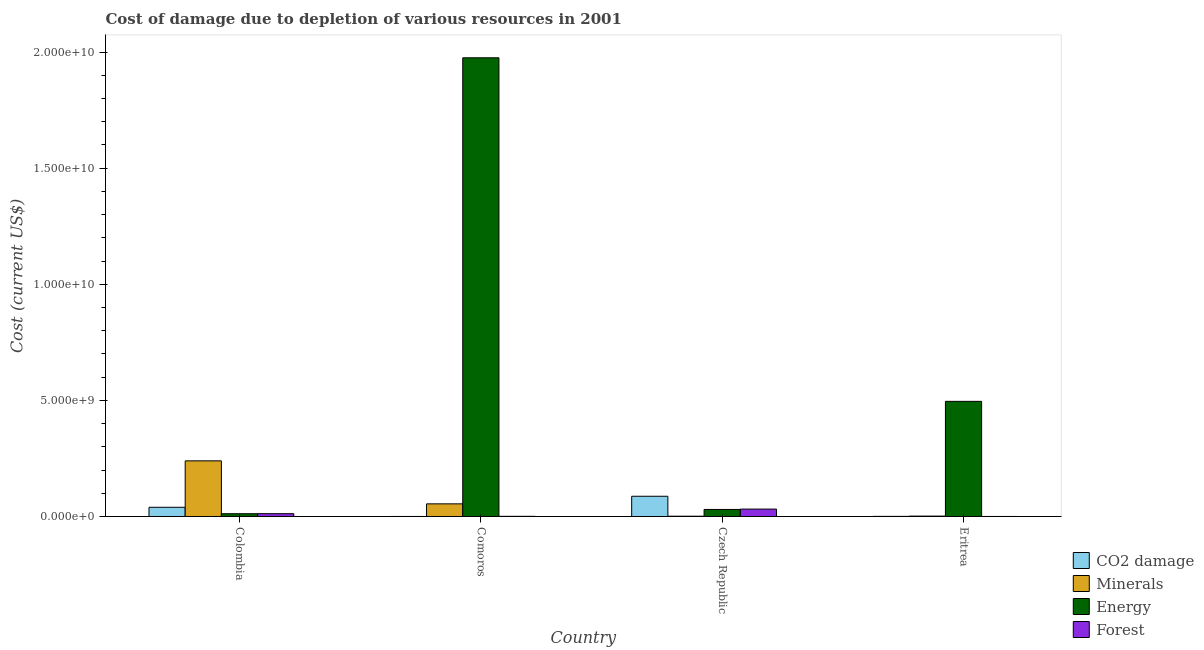How many different coloured bars are there?
Give a very brief answer. 4. How many groups of bars are there?
Provide a short and direct response. 4. What is the label of the 4th group of bars from the left?
Make the answer very short. Eritrea. What is the cost of damage due to depletion of coal in Colombia?
Ensure brevity in your answer.  3.97e+08. Across all countries, what is the maximum cost of damage due to depletion of forests?
Provide a succinct answer. 3.19e+08. Across all countries, what is the minimum cost of damage due to depletion of energy?
Provide a succinct answer. 1.19e+08. In which country was the cost of damage due to depletion of minerals maximum?
Make the answer very short. Colombia. In which country was the cost of damage due to depletion of coal minimum?
Ensure brevity in your answer.  Comoros. What is the total cost of damage due to depletion of minerals in the graph?
Provide a short and direct response. 2.97e+09. What is the difference between the cost of damage due to depletion of coal in Colombia and that in Czech Republic?
Your answer should be compact. -4.74e+08. What is the difference between the cost of damage due to depletion of minerals in Comoros and the cost of damage due to depletion of energy in Czech Republic?
Offer a very short reply. 2.41e+08. What is the average cost of damage due to depletion of minerals per country?
Provide a succinct answer. 7.42e+08. What is the difference between the cost of damage due to depletion of forests and cost of damage due to depletion of energy in Colombia?
Ensure brevity in your answer.  1.68e+06. In how many countries, is the cost of damage due to depletion of minerals greater than 10000000000 US$?
Ensure brevity in your answer.  0. What is the ratio of the cost of damage due to depletion of forests in Comoros to that in Eritrea?
Provide a short and direct response. 157.57. What is the difference between the highest and the second highest cost of damage due to depletion of forests?
Your answer should be very brief. 1.98e+08. What is the difference between the highest and the lowest cost of damage due to depletion of forests?
Offer a terse response. 3.19e+08. In how many countries, is the cost of damage due to depletion of forests greater than the average cost of damage due to depletion of forests taken over all countries?
Offer a terse response. 2. Is it the case that in every country, the sum of the cost of damage due to depletion of forests and cost of damage due to depletion of energy is greater than the sum of cost of damage due to depletion of minerals and cost of damage due to depletion of coal?
Provide a succinct answer. No. What does the 4th bar from the left in Czech Republic represents?
Offer a very short reply. Forest. What does the 1st bar from the right in Comoros represents?
Your answer should be compact. Forest. How many bars are there?
Your answer should be very brief. 16. Are all the bars in the graph horizontal?
Your response must be concise. No. How are the legend labels stacked?
Offer a terse response. Vertical. What is the title of the graph?
Offer a very short reply. Cost of damage due to depletion of various resources in 2001 . What is the label or title of the Y-axis?
Give a very brief answer. Cost (current US$). What is the Cost (current US$) in CO2 damage in Colombia?
Keep it short and to the point. 3.97e+08. What is the Cost (current US$) in Minerals in Colombia?
Give a very brief answer. 2.40e+09. What is the Cost (current US$) in Energy in Colombia?
Offer a terse response. 1.19e+08. What is the Cost (current US$) in Forest in Colombia?
Provide a short and direct response. 1.21e+08. What is the Cost (current US$) in CO2 damage in Comoros?
Your answer should be very brief. 6.20e+05. What is the Cost (current US$) in Minerals in Comoros?
Make the answer very short. 5.44e+08. What is the Cost (current US$) of Energy in Comoros?
Your answer should be very brief. 1.98e+1. What is the Cost (current US$) of Forest in Comoros?
Ensure brevity in your answer.  7.16e+06. What is the Cost (current US$) in CO2 damage in Czech Republic?
Ensure brevity in your answer.  8.71e+08. What is the Cost (current US$) in Minerals in Czech Republic?
Offer a very short reply. 1.20e+07. What is the Cost (current US$) in Energy in Czech Republic?
Give a very brief answer. 3.03e+08. What is the Cost (current US$) in Forest in Czech Republic?
Offer a very short reply. 3.19e+08. What is the Cost (current US$) of CO2 damage in Eritrea?
Make the answer very short. 4.45e+06. What is the Cost (current US$) of Minerals in Eritrea?
Your answer should be very brief. 1.64e+07. What is the Cost (current US$) of Energy in Eritrea?
Your answer should be very brief. 4.96e+09. What is the Cost (current US$) in Forest in Eritrea?
Offer a very short reply. 4.54e+04. Across all countries, what is the maximum Cost (current US$) of CO2 damage?
Keep it short and to the point. 8.71e+08. Across all countries, what is the maximum Cost (current US$) in Minerals?
Keep it short and to the point. 2.40e+09. Across all countries, what is the maximum Cost (current US$) in Energy?
Make the answer very short. 1.98e+1. Across all countries, what is the maximum Cost (current US$) of Forest?
Give a very brief answer. 3.19e+08. Across all countries, what is the minimum Cost (current US$) of CO2 damage?
Your answer should be very brief. 6.20e+05. Across all countries, what is the minimum Cost (current US$) in Minerals?
Keep it short and to the point. 1.20e+07. Across all countries, what is the minimum Cost (current US$) in Energy?
Your answer should be very brief. 1.19e+08. Across all countries, what is the minimum Cost (current US$) of Forest?
Provide a short and direct response. 4.54e+04. What is the total Cost (current US$) in CO2 damage in the graph?
Keep it short and to the point. 1.27e+09. What is the total Cost (current US$) of Minerals in the graph?
Ensure brevity in your answer.  2.97e+09. What is the total Cost (current US$) of Energy in the graph?
Provide a short and direct response. 2.51e+1. What is the total Cost (current US$) of Forest in the graph?
Your answer should be compact. 4.47e+08. What is the difference between the Cost (current US$) of CO2 damage in Colombia and that in Comoros?
Offer a terse response. 3.96e+08. What is the difference between the Cost (current US$) in Minerals in Colombia and that in Comoros?
Give a very brief answer. 1.85e+09. What is the difference between the Cost (current US$) in Energy in Colombia and that in Comoros?
Make the answer very short. -1.96e+1. What is the difference between the Cost (current US$) in Forest in Colombia and that in Comoros?
Keep it short and to the point. 1.14e+08. What is the difference between the Cost (current US$) of CO2 damage in Colombia and that in Czech Republic?
Keep it short and to the point. -4.74e+08. What is the difference between the Cost (current US$) of Minerals in Colombia and that in Czech Republic?
Provide a short and direct response. 2.38e+09. What is the difference between the Cost (current US$) of Energy in Colombia and that in Czech Republic?
Provide a succinct answer. -1.84e+08. What is the difference between the Cost (current US$) in Forest in Colombia and that in Czech Republic?
Offer a very short reply. -1.98e+08. What is the difference between the Cost (current US$) in CO2 damage in Colombia and that in Eritrea?
Make the answer very short. 3.92e+08. What is the difference between the Cost (current US$) in Minerals in Colombia and that in Eritrea?
Your answer should be very brief. 2.38e+09. What is the difference between the Cost (current US$) in Energy in Colombia and that in Eritrea?
Your response must be concise. -4.84e+09. What is the difference between the Cost (current US$) of Forest in Colombia and that in Eritrea?
Keep it short and to the point. 1.21e+08. What is the difference between the Cost (current US$) in CO2 damage in Comoros and that in Czech Republic?
Keep it short and to the point. -8.70e+08. What is the difference between the Cost (current US$) of Minerals in Comoros and that in Czech Republic?
Your answer should be compact. 5.32e+08. What is the difference between the Cost (current US$) of Energy in Comoros and that in Czech Republic?
Provide a short and direct response. 1.94e+1. What is the difference between the Cost (current US$) of Forest in Comoros and that in Czech Republic?
Offer a terse response. -3.11e+08. What is the difference between the Cost (current US$) in CO2 damage in Comoros and that in Eritrea?
Offer a very short reply. -3.82e+06. What is the difference between the Cost (current US$) of Minerals in Comoros and that in Eritrea?
Provide a succinct answer. 5.28e+08. What is the difference between the Cost (current US$) of Energy in Comoros and that in Eritrea?
Make the answer very short. 1.48e+1. What is the difference between the Cost (current US$) in Forest in Comoros and that in Eritrea?
Keep it short and to the point. 7.11e+06. What is the difference between the Cost (current US$) of CO2 damage in Czech Republic and that in Eritrea?
Offer a terse response. 8.66e+08. What is the difference between the Cost (current US$) of Minerals in Czech Republic and that in Eritrea?
Provide a succinct answer. -4.46e+06. What is the difference between the Cost (current US$) in Energy in Czech Republic and that in Eritrea?
Keep it short and to the point. -4.65e+09. What is the difference between the Cost (current US$) in Forest in Czech Republic and that in Eritrea?
Provide a short and direct response. 3.19e+08. What is the difference between the Cost (current US$) of CO2 damage in Colombia and the Cost (current US$) of Minerals in Comoros?
Ensure brevity in your answer.  -1.48e+08. What is the difference between the Cost (current US$) of CO2 damage in Colombia and the Cost (current US$) of Energy in Comoros?
Provide a short and direct response. -1.94e+1. What is the difference between the Cost (current US$) in CO2 damage in Colombia and the Cost (current US$) in Forest in Comoros?
Your answer should be compact. 3.89e+08. What is the difference between the Cost (current US$) in Minerals in Colombia and the Cost (current US$) in Energy in Comoros?
Your answer should be very brief. -1.74e+1. What is the difference between the Cost (current US$) of Minerals in Colombia and the Cost (current US$) of Forest in Comoros?
Ensure brevity in your answer.  2.39e+09. What is the difference between the Cost (current US$) in Energy in Colombia and the Cost (current US$) in Forest in Comoros?
Offer a terse response. 1.12e+08. What is the difference between the Cost (current US$) of CO2 damage in Colombia and the Cost (current US$) of Minerals in Czech Republic?
Keep it short and to the point. 3.85e+08. What is the difference between the Cost (current US$) in CO2 damage in Colombia and the Cost (current US$) in Energy in Czech Republic?
Your answer should be very brief. 9.35e+07. What is the difference between the Cost (current US$) in CO2 damage in Colombia and the Cost (current US$) in Forest in Czech Republic?
Keep it short and to the point. 7.80e+07. What is the difference between the Cost (current US$) in Minerals in Colombia and the Cost (current US$) in Energy in Czech Republic?
Your response must be concise. 2.09e+09. What is the difference between the Cost (current US$) in Minerals in Colombia and the Cost (current US$) in Forest in Czech Republic?
Offer a terse response. 2.08e+09. What is the difference between the Cost (current US$) of Energy in Colombia and the Cost (current US$) of Forest in Czech Republic?
Your answer should be very brief. -2.00e+08. What is the difference between the Cost (current US$) of CO2 damage in Colombia and the Cost (current US$) of Minerals in Eritrea?
Your answer should be compact. 3.80e+08. What is the difference between the Cost (current US$) in CO2 damage in Colombia and the Cost (current US$) in Energy in Eritrea?
Provide a succinct answer. -4.56e+09. What is the difference between the Cost (current US$) of CO2 damage in Colombia and the Cost (current US$) of Forest in Eritrea?
Keep it short and to the point. 3.97e+08. What is the difference between the Cost (current US$) in Minerals in Colombia and the Cost (current US$) in Energy in Eritrea?
Your response must be concise. -2.56e+09. What is the difference between the Cost (current US$) of Minerals in Colombia and the Cost (current US$) of Forest in Eritrea?
Provide a succinct answer. 2.40e+09. What is the difference between the Cost (current US$) of Energy in Colombia and the Cost (current US$) of Forest in Eritrea?
Keep it short and to the point. 1.19e+08. What is the difference between the Cost (current US$) of CO2 damage in Comoros and the Cost (current US$) of Minerals in Czech Republic?
Provide a succinct answer. -1.13e+07. What is the difference between the Cost (current US$) in CO2 damage in Comoros and the Cost (current US$) in Energy in Czech Republic?
Your answer should be compact. -3.03e+08. What is the difference between the Cost (current US$) in CO2 damage in Comoros and the Cost (current US$) in Forest in Czech Republic?
Make the answer very short. -3.18e+08. What is the difference between the Cost (current US$) in Minerals in Comoros and the Cost (current US$) in Energy in Czech Republic?
Offer a very short reply. 2.41e+08. What is the difference between the Cost (current US$) of Minerals in Comoros and the Cost (current US$) of Forest in Czech Republic?
Make the answer very short. 2.26e+08. What is the difference between the Cost (current US$) in Energy in Comoros and the Cost (current US$) in Forest in Czech Republic?
Your response must be concise. 1.94e+1. What is the difference between the Cost (current US$) in CO2 damage in Comoros and the Cost (current US$) in Minerals in Eritrea?
Offer a terse response. -1.58e+07. What is the difference between the Cost (current US$) of CO2 damage in Comoros and the Cost (current US$) of Energy in Eritrea?
Offer a very short reply. -4.96e+09. What is the difference between the Cost (current US$) in CO2 damage in Comoros and the Cost (current US$) in Forest in Eritrea?
Your answer should be very brief. 5.75e+05. What is the difference between the Cost (current US$) of Minerals in Comoros and the Cost (current US$) of Energy in Eritrea?
Your answer should be compact. -4.41e+09. What is the difference between the Cost (current US$) in Minerals in Comoros and the Cost (current US$) in Forest in Eritrea?
Provide a succinct answer. 5.44e+08. What is the difference between the Cost (current US$) of Energy in Comoros and the Cost (current US$) of Forest in Eritrea?
Give a very brief answer. 1.98e+1. What is the difference between the Cost (current US$) of CO2 damage in Czech Republic and the Cost (current US$) of Minerals in Eritrea?
Your response must be concise. 8.54e+08. What is the difference between the Cost (current US$) in CO2 damage in Czech Republic and the Cost (current US$) in Energy in Eritrea?
Your answer should be compact. -4.09e+09. What is the difference between the Cost (current US$) of CO2 damage in Czech Republic and the Cost (current US$) of Forest in Eritrea?
Your answer should be compact. 8.71e+08. What is the difference between the Cost (current US$) of Minerals in Czech Republic and the Cost (current US$) of Energy in Eritrea?
Give a very brief answer. -4.95e+09. What is the difference between the Cost (current US$) of Minerals in Czech Republic and the Cost (current US$) of Forest in Eritrea?
Provide a succinct answer. 1.19e+07. What is the difference between the Cost (current US$) of Energy in Czech Republic and the Cost (current US$) of Forest in Eritrea?
Your answer should be very brief. 3.03e+08. What is the average Cost (current US$) in CO2 damage per country?
Your answer should be compact. 3.18e+08. What is the average Cost (current US$) in Minerals per country?
Provide a succinct answer. 7.42e+08. What is the average Cost (current US$) of Energy per country?
Your answer should be compact. 6.28e+09. What is the average Cost (current US$) in Forest per country?
Offer a very short reply. 1.12e+08. What is the difference between the Cost (current US$) in CO2 damage and Cost (current US$) in Minerals in Colombia?
Ensure brevity in your answer.  -2.00e+09. What is the difference between the Cost (current US$) of CO2 damage and Cost (current US$) of Energy in Colombia?
Keep it short and to the point. 2.77e+08. What is the difference between the Cost (current US$) of CO2 damage and Cost (current US$) of Forest in Colombia?
Give a very brief answer. 2.76e+08. What is the difference between the Cost (current US$) in Minerals and Cost (current US$) in Energy in Colombia?
Provide a short and direct response. 2.28e+09. What is the difference between the Cost (current US$) of Minerals and Cost (current US$) of Forest in Colombia?
Keep it short and to the point. 2.27e+09. What is the difference between the Cost (current US$) of Energy and Cost (current US$) of Forest in Colombia?
Ensure brevity in your answer.  -1.68e+06. What is the difference between the Cost (current US$) of CO2 damage and Cost (current US$) of Minerals in Comoros?
Ensure brevity in your answer.  -5.44e+08. What is the difference between the Cost (current US$) in CO2 damage and Cost (current US$) in Energy in Comoros?
Your answer should be compact. -1.98e+1. What is the difference between the Cost (current US$) of CO2 damage and Cost (current US$) of Forest in Comoros?
Keep it short and to the point. -6.54e+06. What is the difference between the Cost (current US$) of Minerals and Cost (current US$) of Energy in Comoros?
Your answer should be very brief. -1.92e+1. What is the difference between the Cost (current US$) of Minerals and Cost (current US$) of Forest in Comoros?
Make the answer very short. 5.37e+08. What is the difference between the Cost (current US$) in Energy and Cost (current US$) in Forest in Comoros?
Give a very brief answer. 1.97e+1. What is the difference between the Cost (current US$) in CO2 damage and Cost (current US$) in Minerals in Czech Republic?
Your answer should be very brief. 8.59e+08. What is the difference between the Cost (current US$) of CO2 damage and Cost (current US$) of Energy in Czech Republic?
Provide a short and direct response. 5.68e+08. What is the difference between the Cost (current US$) in CO2 damage and Cost (current US$) in Forest in Czech Republic?
Your answer should be very brief. 5.52e+08. What is the difference between the Cost (current US$) of Minerals and Cost (current US$) of Energy in Czech Republic?
Offer a terse response. -2.91e+08. What is the difference between the Cost (current US$) in Minerals and Cost (current US$) in Forest in Czech Republic?
Ensure brevity in your answer.  -3.07e+08. What is the difference between the Cost (current US$) in Energy and Cost (current US$) in Forest in Czech Republic?
Offer a terse response. -1.55e+07. What is the difference between the Cost (current US$) in CO2 damage and Cost (current US$) in Minerals in Eritrea?
Your response must be concise. -1.20e+07. What is the difference between the Cost (current US$) of CO2 damage and Cost (current US$) of Energy in Eritrea?
Make the answer very short. -4.95e+09. What is the difference between the Cost (current US$) in CO2 damage and Cost (current US$) in Forest in Eritrea?
Make the answer very short. 4.40e+06. What is the difference between the Cost (current US$) in Minerals and Cost (current US$) in Energy in Eritrea?
Provide a short and direct response. -4.94e+09. What is the difference between the Cost (current US$) in Minerals and Cost (current US$) in Forest in Eritrea?
Keep it short and to the point. 1.64e+07. What is the difference between the Cost (current US$) of Energy and Cost (current US$) of Forest in Eritrea?
Your answer should be very brief. 4.96e+09. What is the ratio of the Cost (current US$) in CO2 damage in Colombia to that in Comoros?
Provide a succinct answer. 639.42. What is the ratio of the Cost (current US$) in Minerals in Colombia to that in Comoros?
Keep it short and to the point. 4.4. What is the ratio of the Cost (current US$) in Energy in Colombia to that in Comoros?
Provide a succinct answer. 0.01. What is the ratio of the Cost (current US$) of Forest in Colombia to that in Comoros?
Make the answer very short. 16.87. What is the ratio of the Cost (current US$) in CO2 damage in Colombia to that in Czech Republic?
Your answer should be compact. 0.46. What is the ratio of the Cost (current US$) in Minerals in Colombia to that in Czech Republic?
Your response must be concise. 200.21. What is the ratio of the Cost (current US$) in Energy in Colombia to that in Czech Republic?
Make the answer very short. 0.39. What is the ratio of the Cost (current US$) in Forest in Colombia to that in Czech Republic?
Make the answer very short. 0.38. What is the ratio of the Cost (current US$) of CO2 damage in Colombia to that in Eritrea?
Ensure brevity in your answer.  89.22. What is the ratio of the Cost (current US$) of Minerals in Colombia to that in Eritrea?
Give a very brief answer. 145.82. What is the ratio of the Cost (current US$) in Energy in Colombia to that in Eritrea?
Give a very brief answer. 0.02. What is the ratio of the Cost (current US$) in Forest in Colombia to that in Eritrea?
Your response must be concise. 2658.58. What is the ratio of the Cost (current US$) of CO2 damage in Comoros to that in Czech Republic?
Offer a terse response. 0. What is the ratio of the Cost (current US$) of Minerals in Comoros to that in Czech Republic?
Your answer should be very brief. 45.48. What is the ratio of the Cost (current US$) of Energy in Comoros to that in Czech Republic?
Your response must be concise. 65.16. What is the ratio of the Cost (current US$) in Forest in Comoros to that in Czech Republic?
Provide a short and direct response. 0.02. What is the ratio of the Cost (current US$) in CO2 damage in Comoros to that in Eritrea?
Offer a very short reply. 0.14. What is the ratio of the Cost (current US$) of Minerals in Comoros to that in Eritrea?
Give a very brief answer. 33.12. What is the ratio of the Cost (current US$) in Energy in Comoros to that in Eritrea?
Give a very brief answer. 3.98. What is the ratio of the Cost (current US$) of Forest in Comoros to that in Eritrea?
Offer a terse response. 157.57. What is the ratio of the Cost (current US$) in CO2 damage in Czech Republic to that in Eritrea?
Provide a short and direct response. 195.88. What is the ratio of the Cost (current US$) of Minerals in Czech Republic to that in Eritrea?
Provide a short and direct response. 0.73. What is the ratio of the Cost (current US$) of Energy in Czech Republic to that in Eritrea?
Your response must be concise. 0.06. What is the ratio of the Cost (current US$) of Forest in Czech Republic to that in Eritrea?
Provide a succinct answer. 7012.05. What is the difference between the highest and the second highest Cost (current US$) in CO2 damage?
Give a very brief answer. 4.74e+08. What is the difference between the highest and the second highest Cost (current US$) in Minerals?
Provide a short and direct response. 1.85e+09. What is the difference between the highest and the second highest Cost (current US$) in Energy?
Offer a very short reply. 1.48e+1. What is the difference between the highest and the second highest Cost (current US$) in Forest?
Ensure brevity in your answer.  1.98e+08. What is the difference between the highest and the lowest Cost (current US$) in CO2 damage?
Offer a very short reply. 8.70e+08. What is the difference between the highest and the lowest Cost (current US$) in Minerals?
Offer a terse response. 2.38e+09. What is the difference between the highest and the lowest Cost (current US$) in Energy?
Ensure brevity in your answer.  1.96e+1. What is the difference between the highest and the lowest Cost (current US$) in Forest?
Provide a short and direct response. 3.19e+08. 